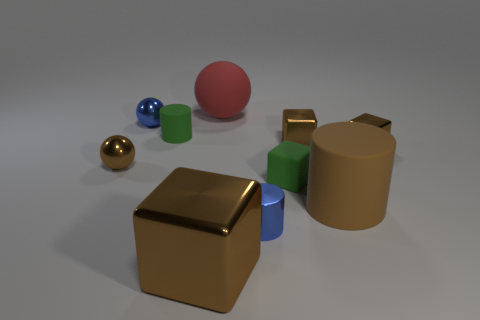Are there more tiny green spheres than tiny things?
Offer a very short reply. No. Is there anything else that is the same color as the small rubber cylinder?
Your response must be concise. Yes. What number of other objects are there of the same size as the red matte sphere?
Provide a succinct answer. 2. There is a small green thing left of the red object on the left side of the big thing that is right of the big red object; what is its material?
Make the answer very short. Rubber. Is the small green block made of the same material as the big cube that is on the left side of the big red matte sphere?
Keep it short and to the point. No. Is the number of tiny brown metallic spheres in front of the brown matte cylinder less than the number of small balls right of the tiny blue shiny sphere?
Your answer should be compact. No. What number of tiny blue cylinders have the same material as the tiny green block?
Your answer should be very brief. 0. Are there any metal blocks in front of the brown metallic object in front of the green object that is in front of the small brown shiny ball?
Your answer should be very brief. No. How many cylinders are either yellow things or big rubber things?
Make the answer very short. 1. Do the large brown shiny thing and the small brown metallic object that is to the left of the red sphere have the same shape?
Offer a very short reply. No. 